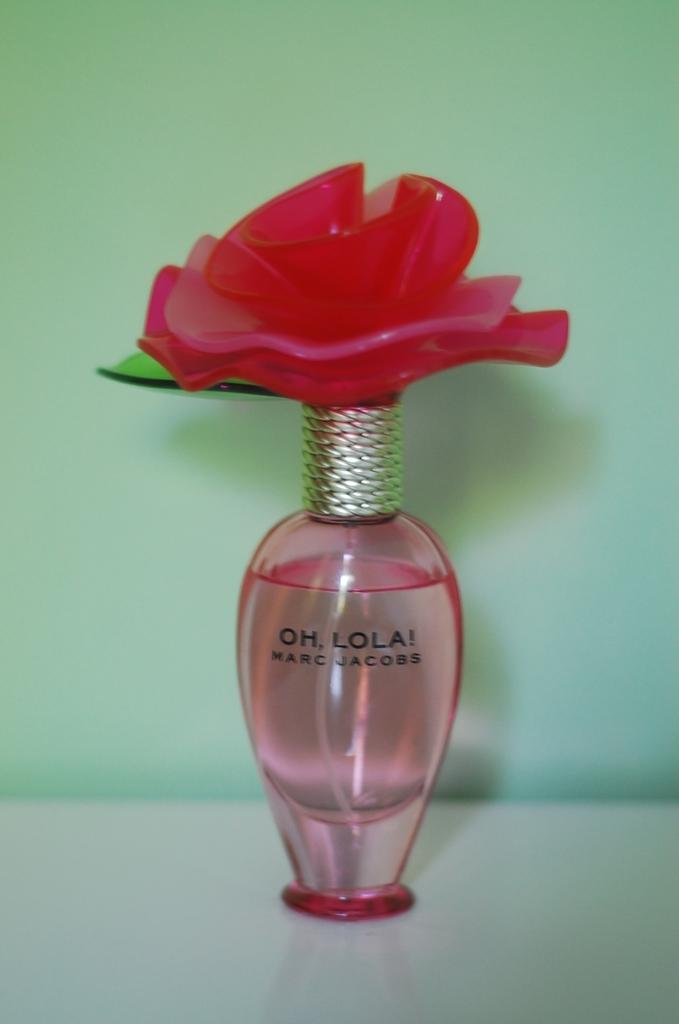<image>
Relay a brief, clear account of the picture shown. A fancy bottle of Oh, Lola! perfume has a red flower on the cap. 